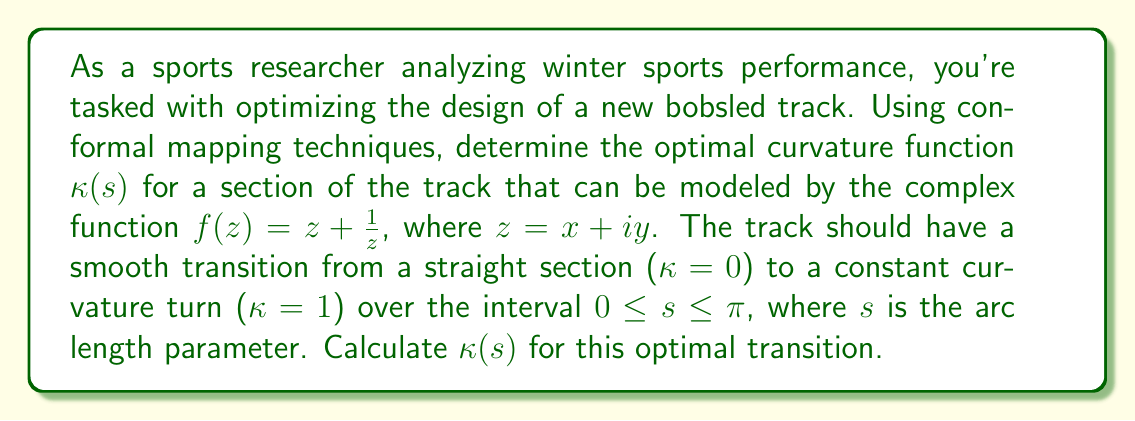Can you solve this math problem? To solve this problem, we'll follow these steps:

1) First, recall that for a complex function $f(z)$, the curvature $\kappa$ is given by:

   $$\kappa = \left|\frac{f''(z)}{f'(z)}\right| \cdot \frac{1}{|f'(z)|}$$

2) Calculate $f'(z)$ and $f''(z)$:
   
   $$f'(z) = 1 - \frac{1}{z^2}$$
   $$f''(z) = \frac{2}{z^3}$$

3) Substitute these into the curvature formula:

   $$\kappa = \left|\frac{2/z^3}{1-1/z^2}\right| \cdot \frac{1}{|1-1/z^2|}$$

4) To simplify, let $z = re^{i\theta}$. Then:

   $$\kappa = \frac{2/r}{r^2-1}$$

5) We want $\kappa$ to transition from 0 to 1 over $0 \leq s \leq \pi$. A smooth transition can be modeled by:

   $$\kappa(s) = \frac{1}{2}(1 - \cos(s))$$

6) This satisfies $\kappa(0) = 0$ and $\kappa(\pi) = 1$.

7) To relate $s$ to $r$, we can use the arc length formula:

   $$s = \int_1^r \frac{|f'(z)|}{|z|} dr = \int_1^r \frac{\sqrt{r^4+1}}{r^2} dr$$

8) While this integral doesn't have a simple closed form, we can use it to numerically relate $r$ and $s$.

9) Combining steps 5 and 7, we have our optimal curvature function $\kappa(s)$.
Answer: The optimal curvature function for the bobsled track transition is:

$$\kappa(s) = \frac{1}{2}(1 - \cos(s))$$

where $0 \leq s \leq \pi$, and $s$ is related to the radial coordinate $r$ by:

$$s = \int_1^r \frac{\sqrt{r^4+1}}{r^2} dr$$ 